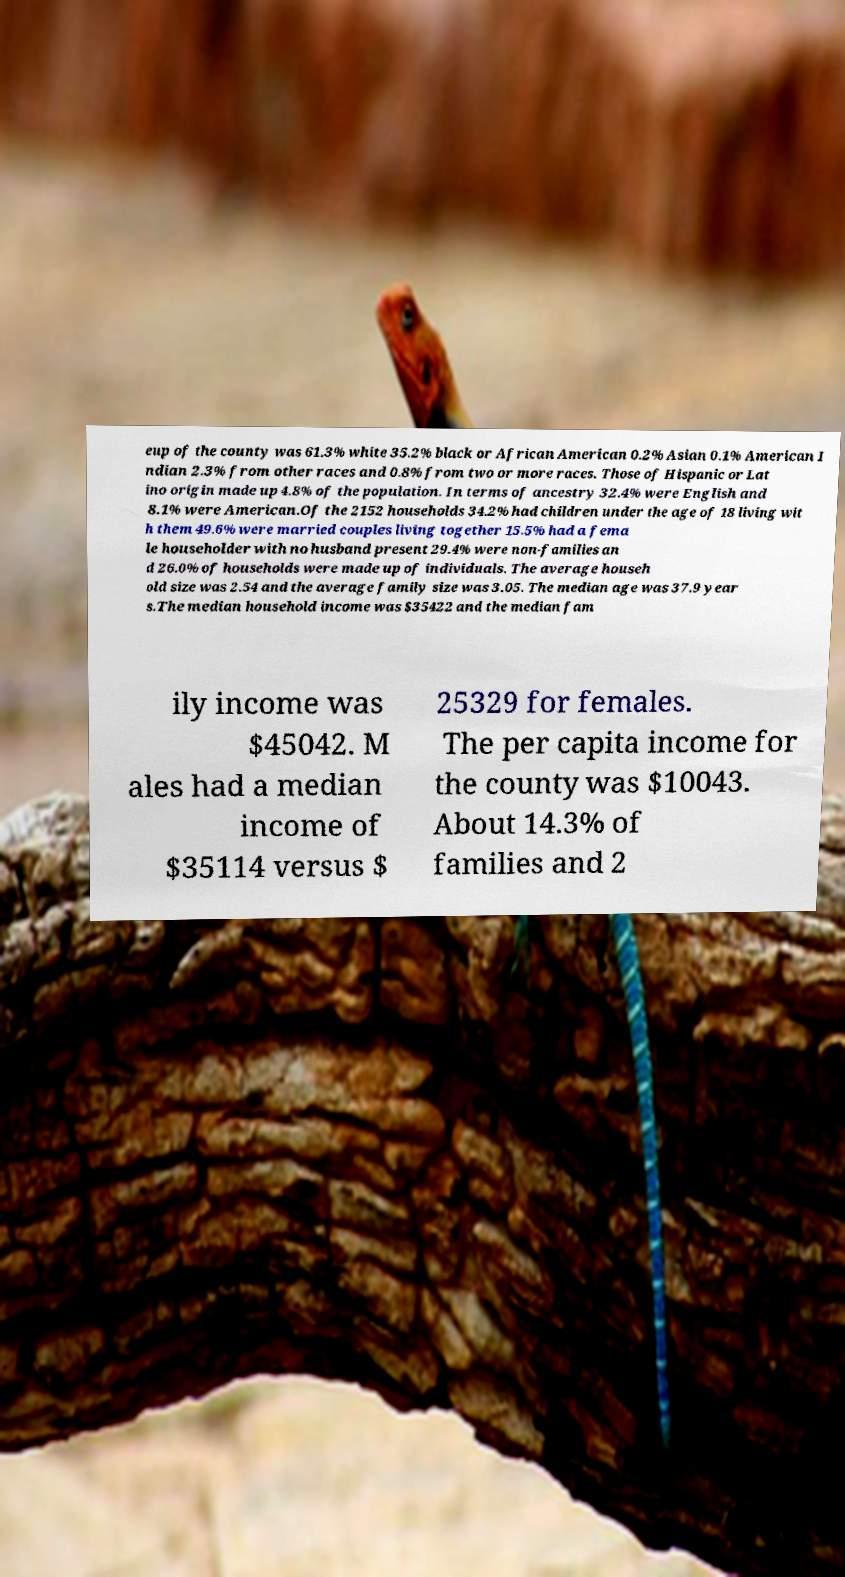What messages or text are displayed in this image? I need them in a readable, typed format. eup of the county was 61.3% white 35.2% black or African American 0.2% Asian 0.1% American I ndian 2.3% from other races and 0.8% from two or more races. Those of Hispanic or Lat ino origin made up 4.8% of the population. In terms of ancestry 32.4% were English and 8.1% were American.Of the 2152 households 34.2% had children under the age of 18 living wit h them 49.6% were married couples living together 15.5% had a fema le householder with no husband present 29.4% were non-families an d 26.0% of households were made up of individuals. The average househ old size was 2.54 and the average family size was 3.05. The median age was 37.9 year s.The median household income was $35422 and the median fam ily income was $45042. M ales had a median income of $35114 versus $ 25329 for females. The per capita income for the county was $10043. About 14.3% of families and 2 